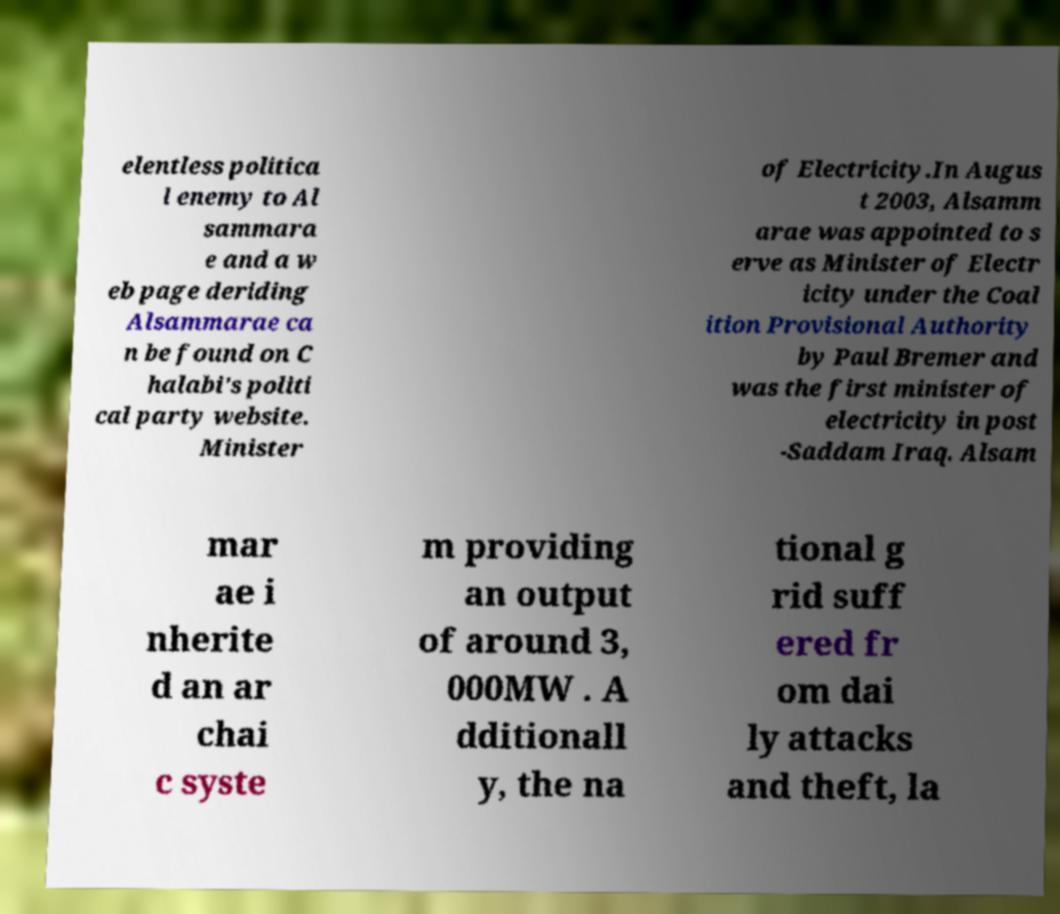For documentation purposes, I need the text within this image transcribed. Could you provide that? elentless politica l enemy to Al sammara e and a w eb page deriding Alsammarae ca n be found on C halabi's politi cal party website. Minister of Electricity.In Augus t 2003, Alsamm arae was appointed to s erve as Minister of Electr icity under the Coal ition Provisional Authority by Paul Bremer and was the first minister of electricity in post -Saddam Iraq. Alsam mar ae i nherite d an ar chai c syste m providing an output of around 3, 000MW . A dditionall y, the na tional g rid suff ered fr om dai ly attacks and theft, la 